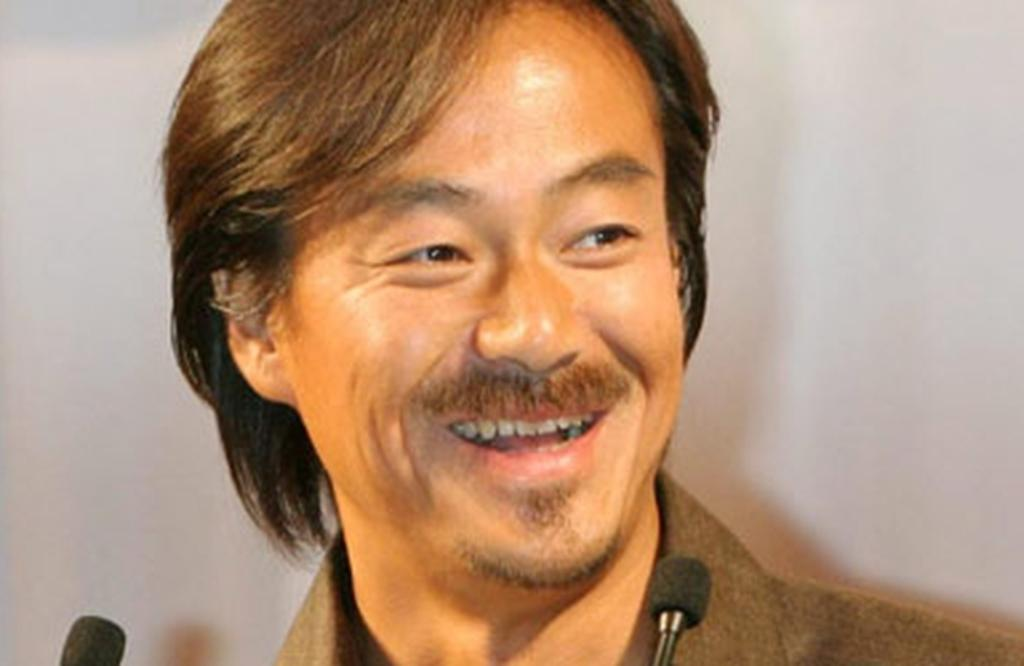Who is present in the image? There is a man in the image. What is the man doing in the image? The man is smiling in the image. What objects are in front of the man? There are microphones in front of the man. Can you describe the background of the image? The background of the image is blurred. What type of lamp is on the man's nose in the image? There is no lamp present on the man's nose in the image. What color is the vest the man is wearing in the image? The man is not wearing a vest in the image. 